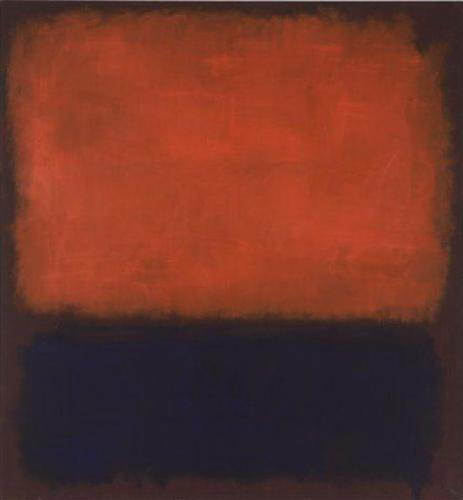How would you explain the significance of this painting to a child? Imagine this painting as a big red blanket and a dark black floor underneath it. The red part is like a bumpy, textured area that feels rough, like tree bark, and the black part is smooth and calm, like a puddle after the rain. The artist wanted to use these colors and textures to tell a story without words. The red can remind us of strong feelings like excitement or anger, and the black can be calming like nighttime. Together, they make us think and feel different things. 